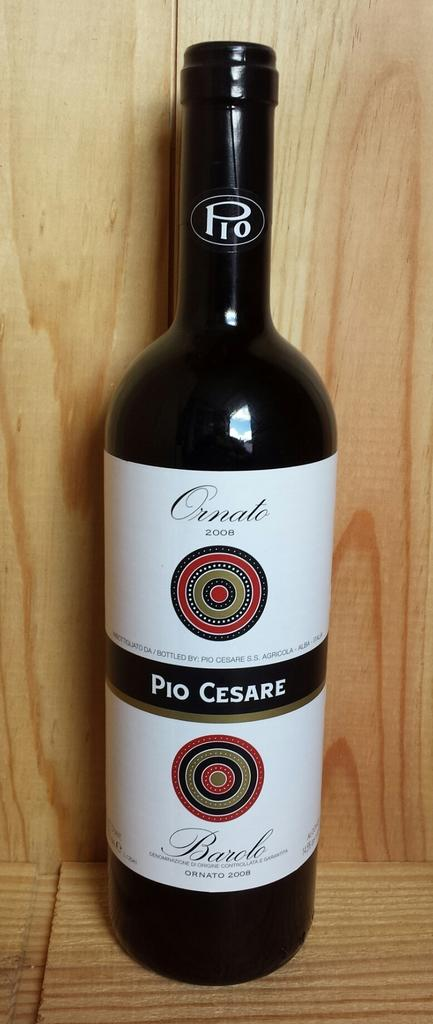<image>
Render a clear and concise summary of the photo. A close up of a bottle of Pio Cesare red wine in a wooden presentation box. 